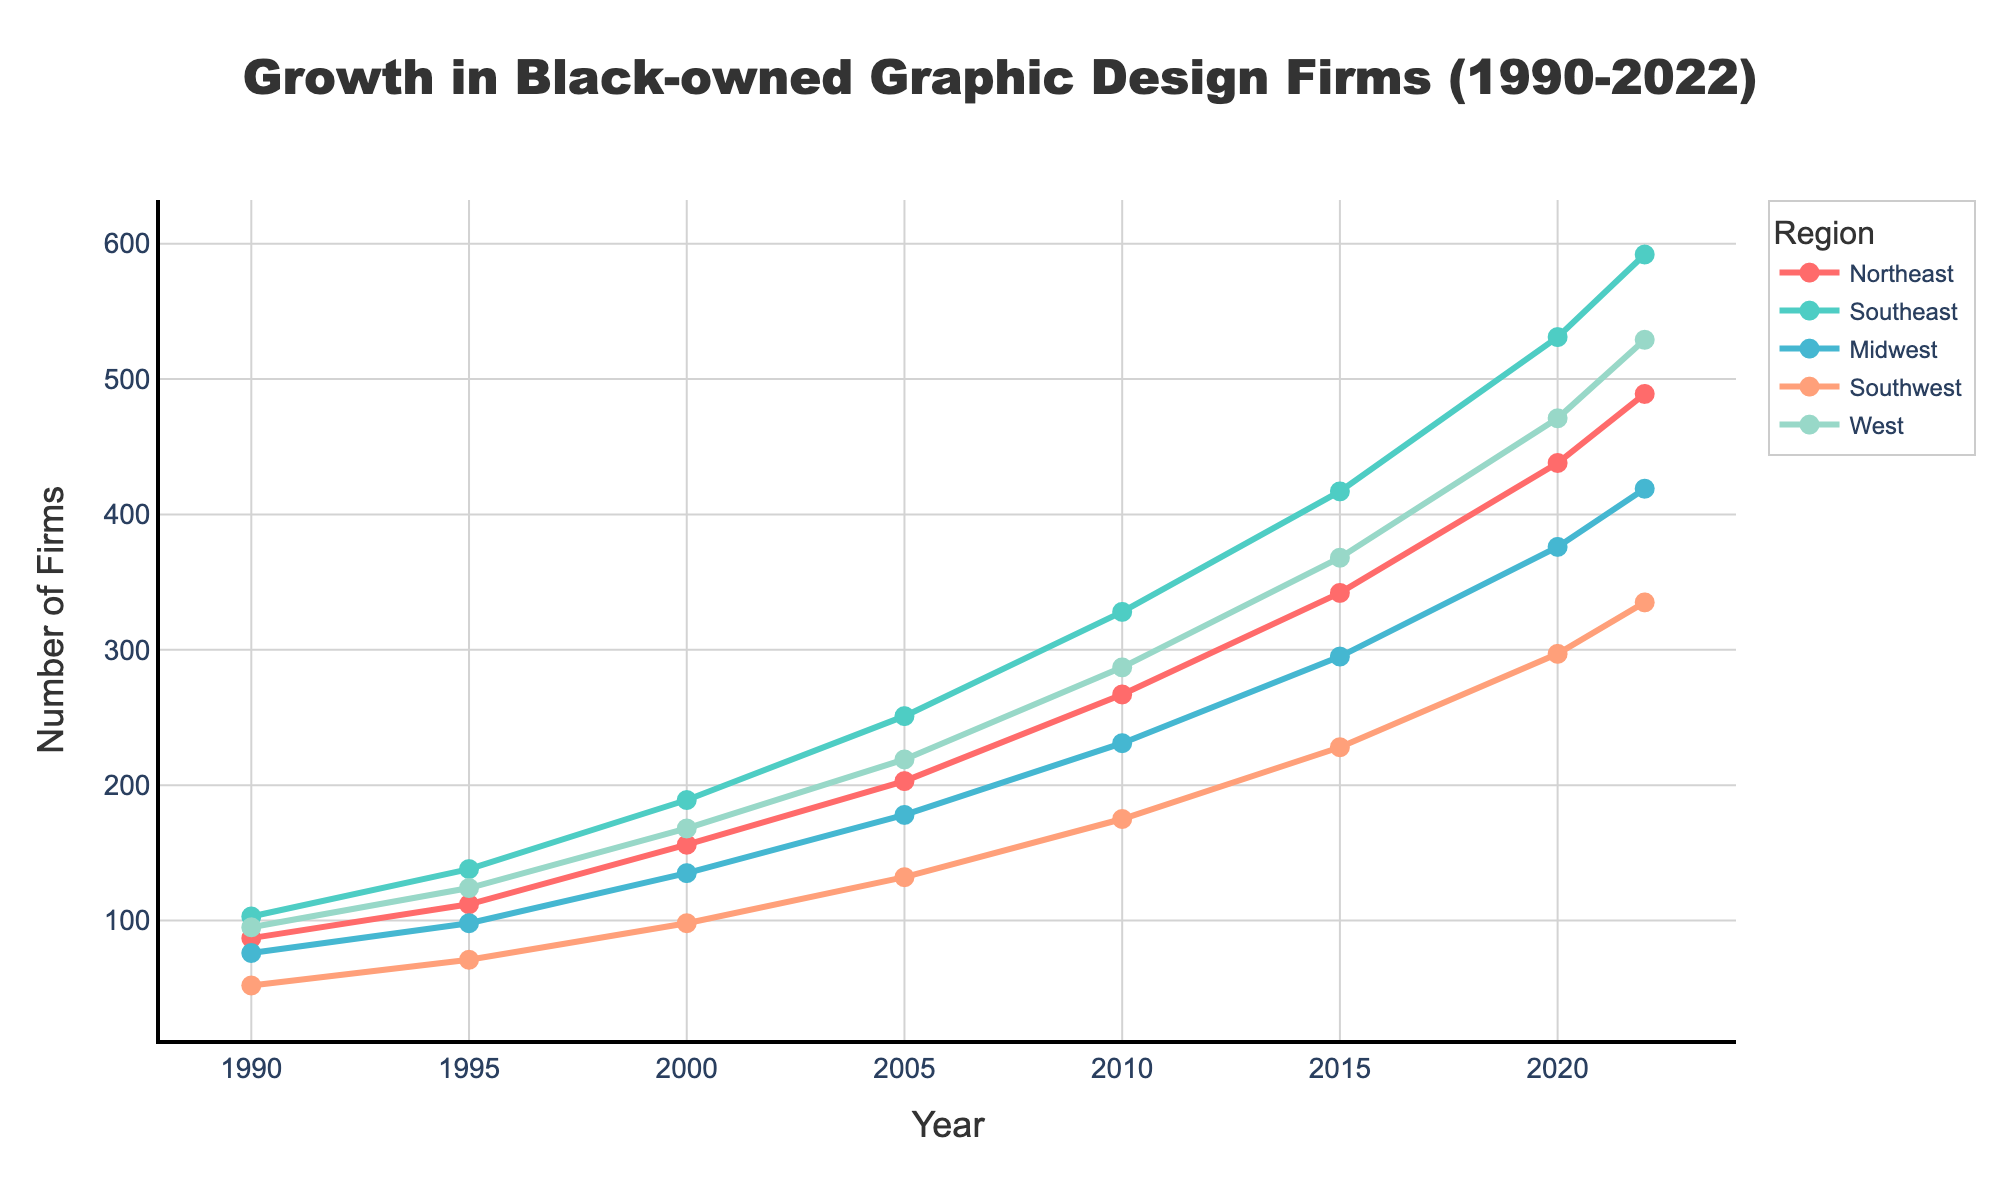What is the overall trend in the number of Black-owned graphic design firms in the West region from 1990 to 2022? The trend of the West region can be observed by looking at the line representing this region, which starts in 1990 at 95 firms and rises steadily, reaching 529 firms in 2022. Overall, the trend is an increase.
Answer: Increase Which region had the highest number of Black-owned graphic design firms in 2022? By examining the endpoints of all the lines in 2022, the Southeast region has the highest number of firms, reaching 592.
Answer: Southeast How much did the number of Black-owned graphic design firms increase in the Northeast from 1990 to 2022? In 1990, the number of firms in the Northeast was 87, and it increased to 489 by 2022. The difference is 489 - 87 = 402.
Answer: 402 Between 2000 and 2020, which region saw the largest increase in the number of Black-owned graphic design firms? By calculating the difference for each region: 
Northeast: 438 - 156 = 282,
Southeast: 531 - 189 = 342,
Midwest: 376 - 135 = 241,
Southwest: 297 - 98 = 199,
West: 471 - 168 = 303.
The Southeast saw the largest increase of 342.
Answer: Southeast Which regions had a number of firms greater than 400 in 2022? By looking at the numbers for 2022, the regions with more than 400 firms are:
Northeast: 489,
Southeast: 592,
West: 529,
Midwest: 419.
Answer: Northeast, Southeast, West, Midwest Did all regions show an increase in Black-owned graphic design firms from 1990 to 2000? Examining the change from 1990 to 2000 for each region:
Northeast: 87 to 156 (increase),
Southeast: 103 to 189 (increase),
Midwest: 76 to 135 (increase),
Southwest: 52 to 98 (increase),
West: 95 to 168 (increase). 
All regions show an increase.
Answer: Yes Approximately how many more Black-owned graphic design firms were there in the Southeast compared to the Southwest in 2010? In 2010, the Southeast had 328 firms, and the Southwest had 175 firms. The difference is 328 - 175 = 153.
Answer: 153 What is the average number of Black-owned graphic design firms in the Midwest over the years 1990, 2000, 2010, and 2020? Adding the numbers for the Midwest for these years: 76 (1990), 135 (2000), 231 (2010), and 376 (2020). Total is 76 + 135 + 231 + 376 = 818. The average is 818 / 4 = 204.5.
Answer: 204.5 Which region had the lowest number of Black-owned graphic design firms in 1990, and what was that number? Looking at the numbers for 1990, the Southwest had the lowest number with 52 firms.
Answer: Southwest By how much did the number of Black-owned graphic design firms in the Southeast grow between 2015 and 2022? In 2015, the number of firms in the Southeast was 417, and it grew to 592 by 2022. The growth is 592 - 417 = 175.
Answer: 175 